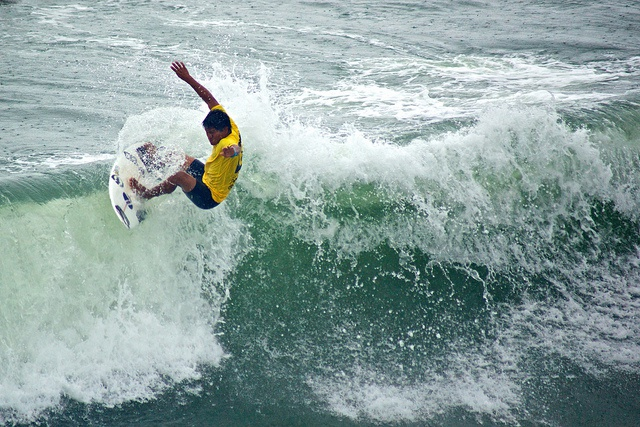Describe the objects in this image and their specific colors. I can see people in black, maroon, and olive tones and surfboard in black, lightgray, darkgray, and gray tones in this image. 